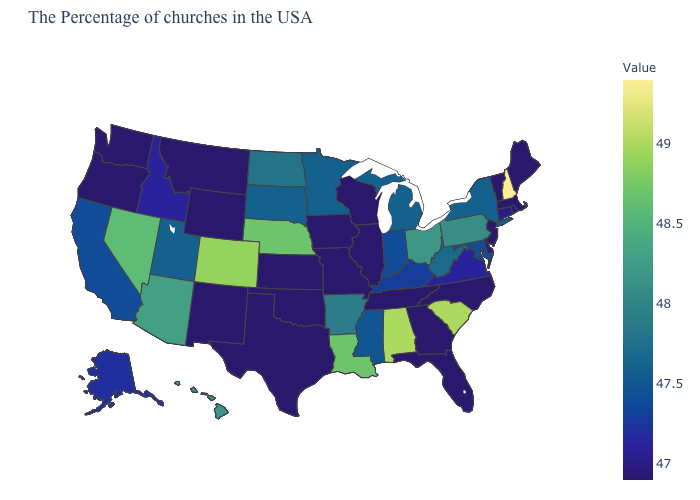Is the legend a continuous bar?
Write a very short answer. Yes. Which states hav the highest value in the MidWest?
Answer briefly. Nebraska. Which states have the highest value in the USA?
Write a very short answer. New Hampshire. Among the states that border Wisconsin , which have the highest value?
Be succinct. Michigan, Minnesota. Does Arizona have the lowest value in the West?
Answer briefly. No. Among the states that border Utah , which have the highest value?
Short answer required. Colorado. Which states have the highest value in the USA?
Short answer required. New Hampshire. 